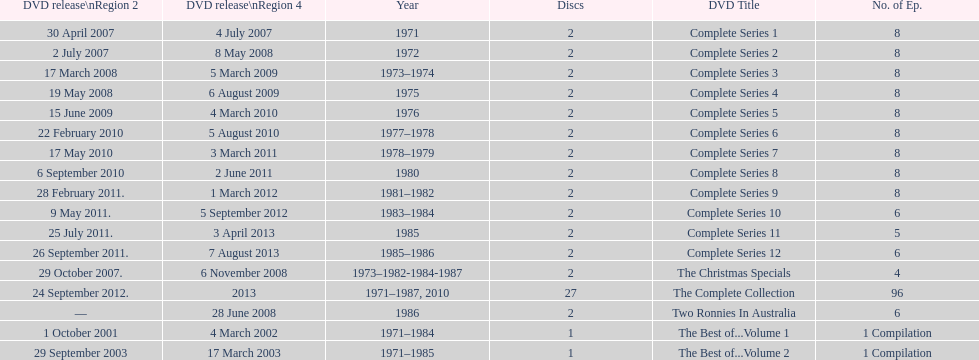Total number of episodes released in region 2 in 2007 20. 